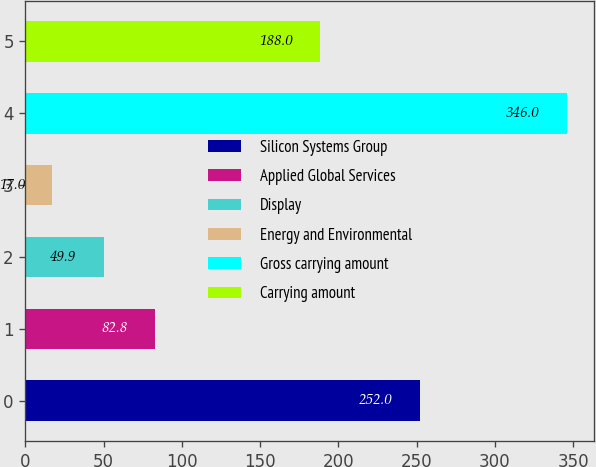Convert chart. <chart><loc_0><loc_0><loc_500><loc_500><bar_chart><fcel>Silicon Systems Group<fcel>Applied Global Services<fcel>Display<fcel>Energy and Environmental<fcel>Gross carrying amount<fcel>Carrying amount<nl><fcel>252<fcel>82.8<fcel>49.9<fcel>17<fcel>346<fcel>188<nl></chart> 